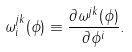Convert formula to latex. <formula><loc_0><loc_0><loc_500><loc_500>\omega _ { i } ^ { j k } ( \phi ) \equiv \frac { \partial \omega ^ { j k } ( \phi ) } { \partial \phi ^ { i } } .</formula> 